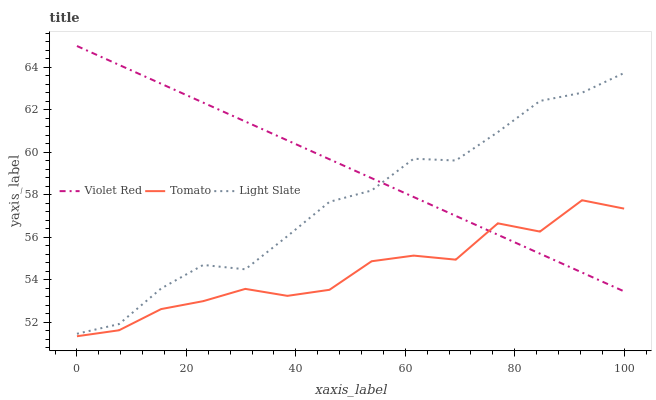Does Tomato have the minimum area under the curve?
Answer yes or no. Yes. Does Violet Red have the maximum area under the curve?
Answer yes or no. Yes. Does Light Slate have the minimum area under the curve?
Answer yes or no. No. Does Light Slate have the maximum area under the curve?
Answer yes or no. No. Is Violet Red the smoothest?
Answer yes or no. Yes. Is Tomato the roughest?
Answer yes or no. Yes. Is Light Slate the smoothest?
Answer yes or no. No. Is Light Slate the roughest?
Answer yes or no. No. Does Tomato have the lowest value?
Answer yes or no. Yes. Does Light Slate have the lowest value?
Answer yes or no. No. Does Violet Red have the highest value?
Answer yes or no. Yes. Does Light Slate have the highest value?
Answer yes or no. No. Is Tomato less than Light Slate?
Answer yes or no. Yes. Is Light Slate greater than Tomato?
Answer yes or no. Yes. Does Violet Red intersect Light Slate?
Answer yes or no. Yes. Is Violet Red less than Light Slate?
Answer yes or no. No. Is Violet Red greater than Light Slate?
Answer yes or no. No. Does Tomato intersect Light Slate?
Answer yes or no. No. 